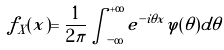Convert formula to latex. <formula><loc_0><loc_0><loc_500><loc_500>f _ { X } ( x ) = \frac { 1 } { 2 \pi } \int _ { - \infty } ^ { + \infty } e ^ { - i \theta x } \varphi ( \theta ) d \theta</formula> 